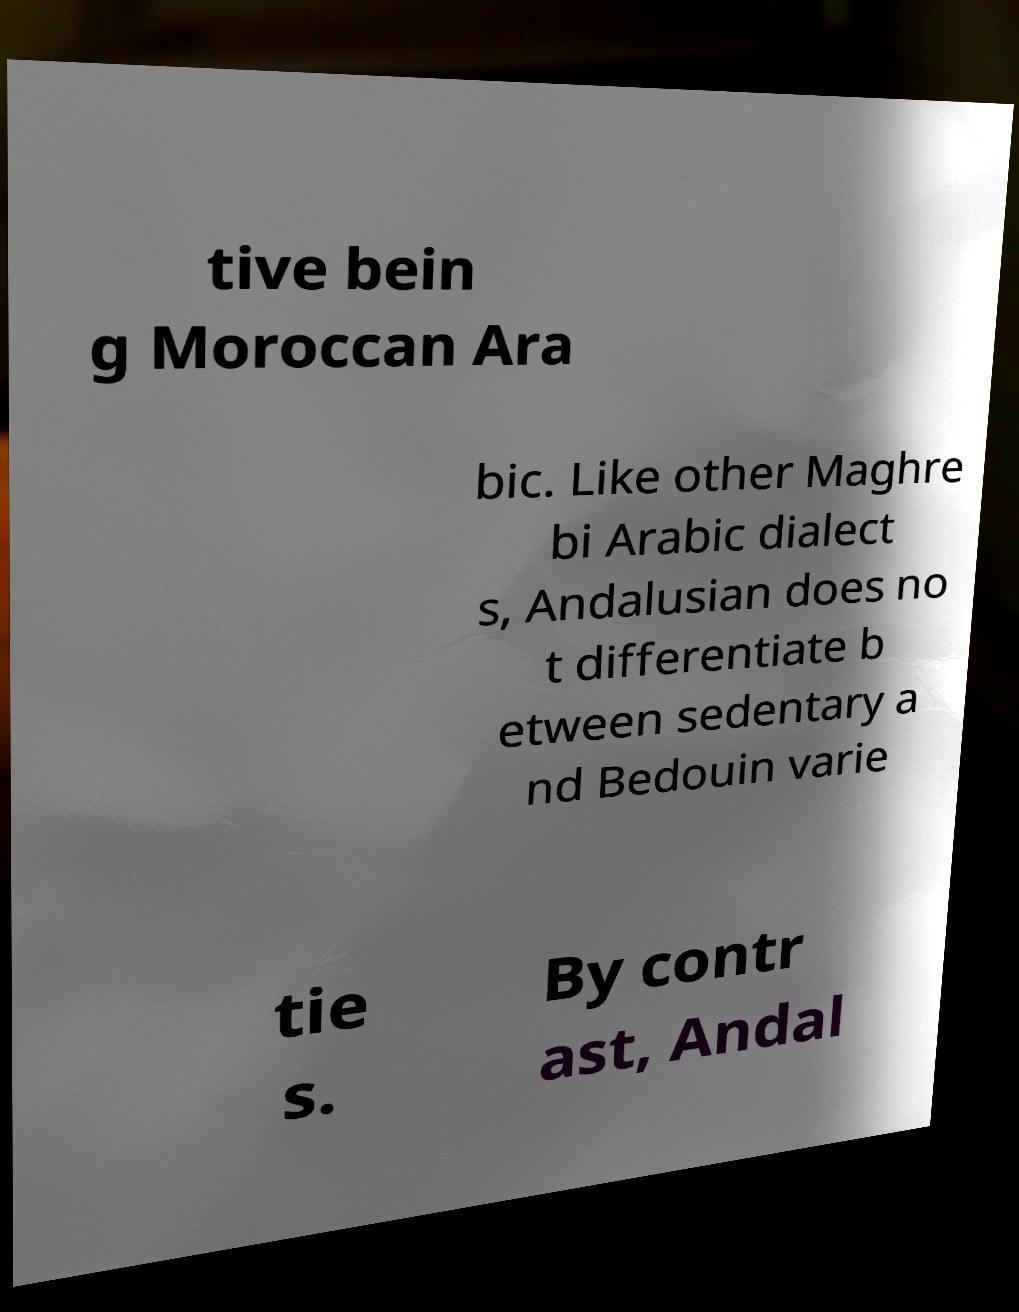Could you extract and type out the text from this image? tive bein g Moroccan Ara bic. Like other Maghre bi Arabic dialect s, Andalusian does no t differentiate b etween sedentary a nd Bedouin varie tie s. By contr ast, Andal 